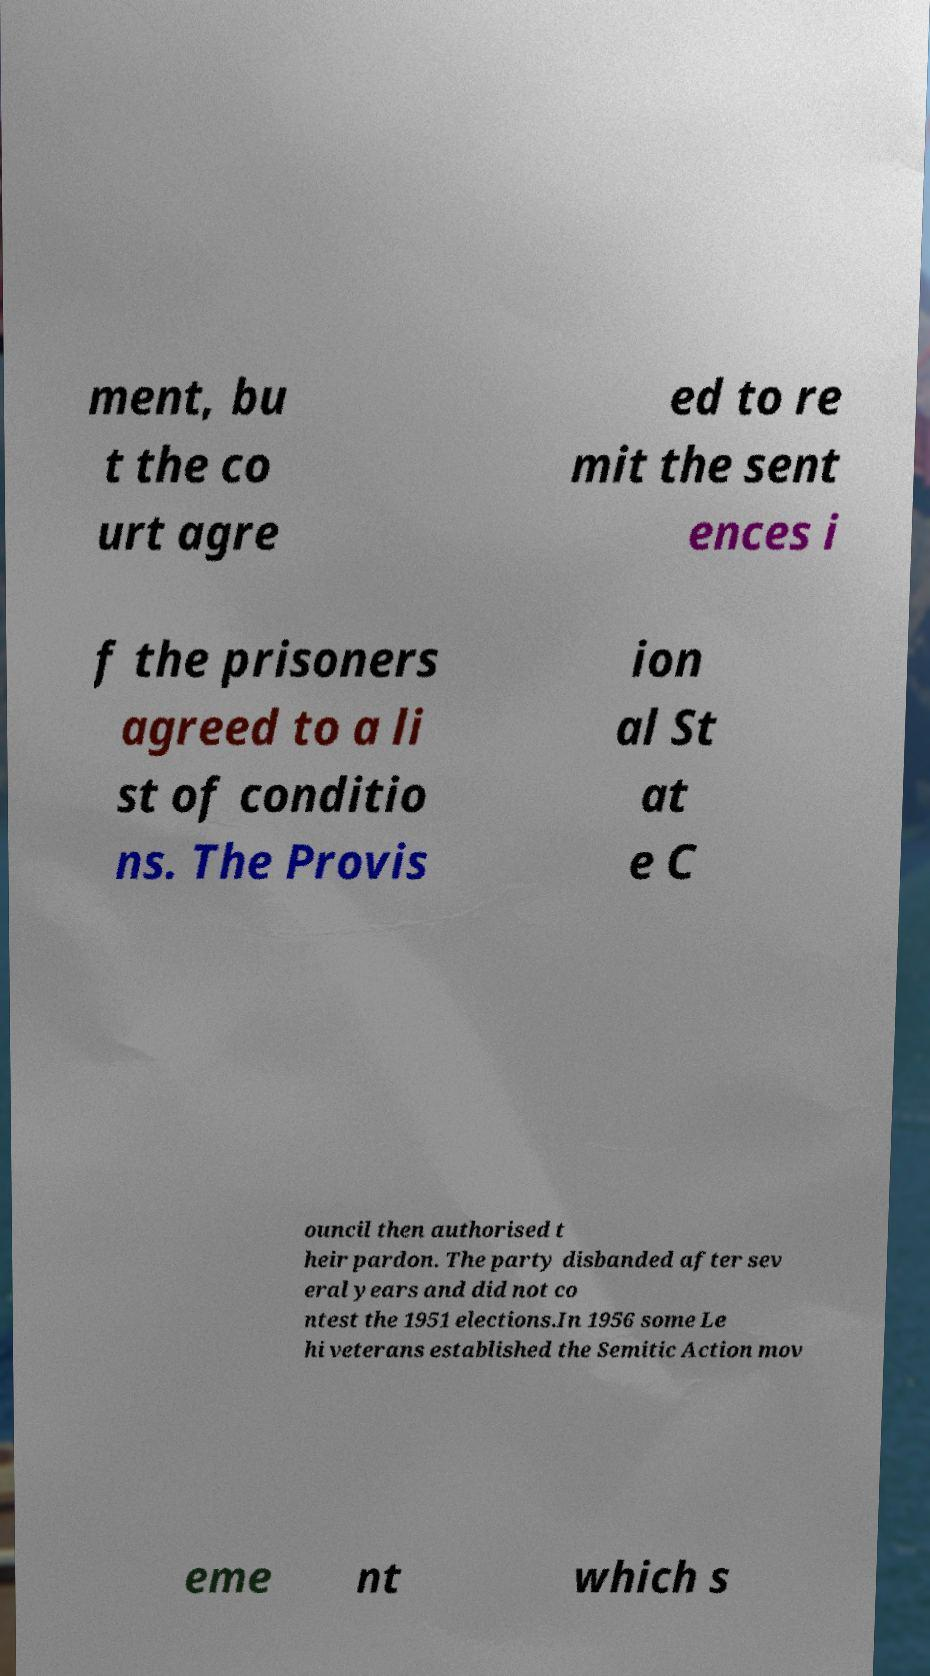Please identify and transcribe the text found in this image. ment, bu t the co urt agre ed to re mit the sent ences i f the prisoners agreed to a li st of conditio ns. The Provis ion al St at e C ouncil then authorised t heir pardon. The party disbanded after sev eral years and did not co ntest the 1951 elections.In 1956 some Le hi veterans established the Semitic Action mov eme nt which s 